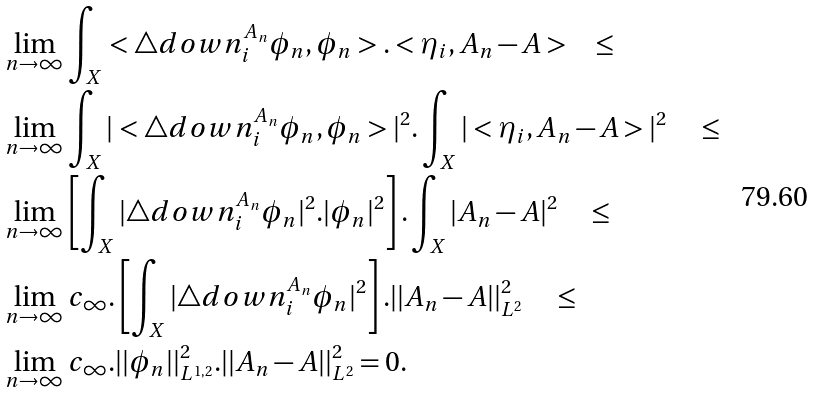<formula> <loc_0><loc_0><loc_500><loc_500>& \lim _ { n \to \infty } \int _ { X } < \triangle d o w n ^ { A _ { n } } _ { i } \phi _ { n } , \phi _ { n } > . < \eta _ { i } , A _ { n } - A > \quad \leq \\ & \lim _ { n \to \infty } \int _ { X } | < \triangle d o w n ^ { A _ { n } } _ { i } \phi _ { n } , \phi _ { n } > | ^ { 2 } . \int _ { X } | < \eta _ { i } , A _ { n } - A > | ^ { 2 } \quad \leq \\ & \lim _ { n \to \infty } \left [ \int _ { X } | \triangle d o w n ^ { A _ { n } } _ { i } \phi _ { n } | ^ { 2 } . | \phi _ { n } | ^ { 2 } \right ] . \int _ { X } | A _ { n } - A | ^ { 2 } \quad \leq \\ & \lim _ { n \to \infty } c _ { \infty } . \left [ \int _ { X } | \triangle d o w n ^ { A _ { n } } _ { i } \phi _ { n } | ^ { 2 } \right ] . | | A _ { n } - A | | ^ { 2 } _ { L ^ { 2 } } \quad \leq \\ & \lim _ { n \to \infty } c _ { \infty } . | | \phi _ { n } | | ^ { 2 } _ { L ^ { 1 , 2 } } . | | A _ { n } - A | | ^ { 2 } _ { L ^ { 2 } } = 0 .</formula> 